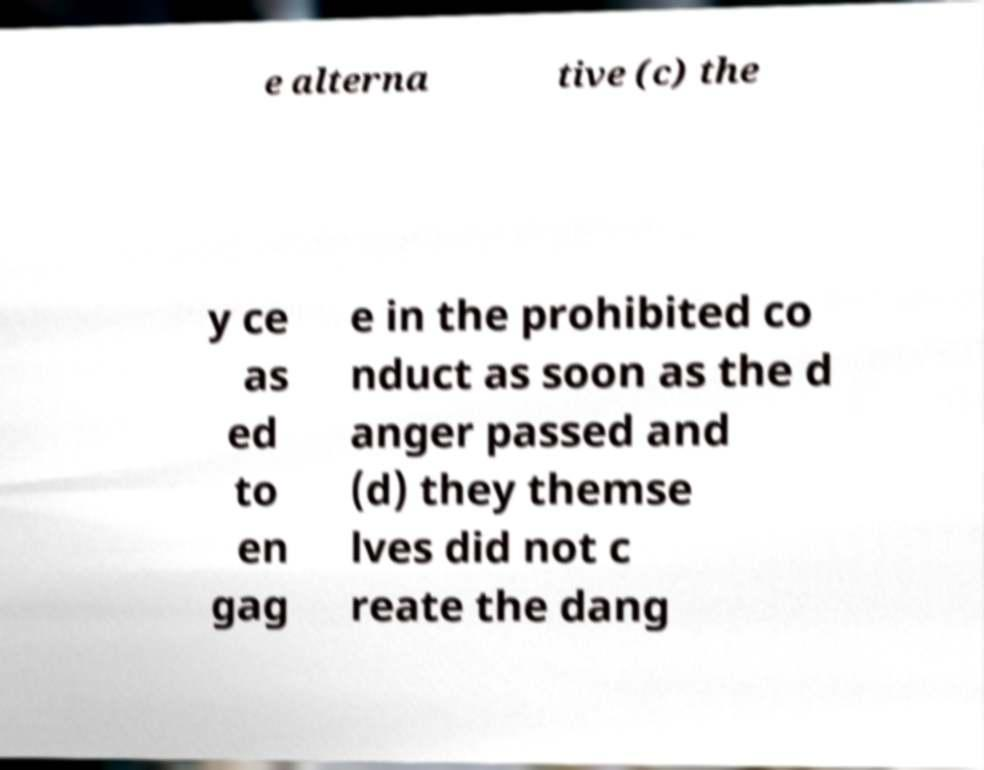There's text embedded in this image that I need extracted. Can you transcribe it verbatim? e alterna tive (c) the y ce as ed to en gag e in the prohibited co nduct as soon as the d anger passed and (d) they themse lves did not c reate the dang 